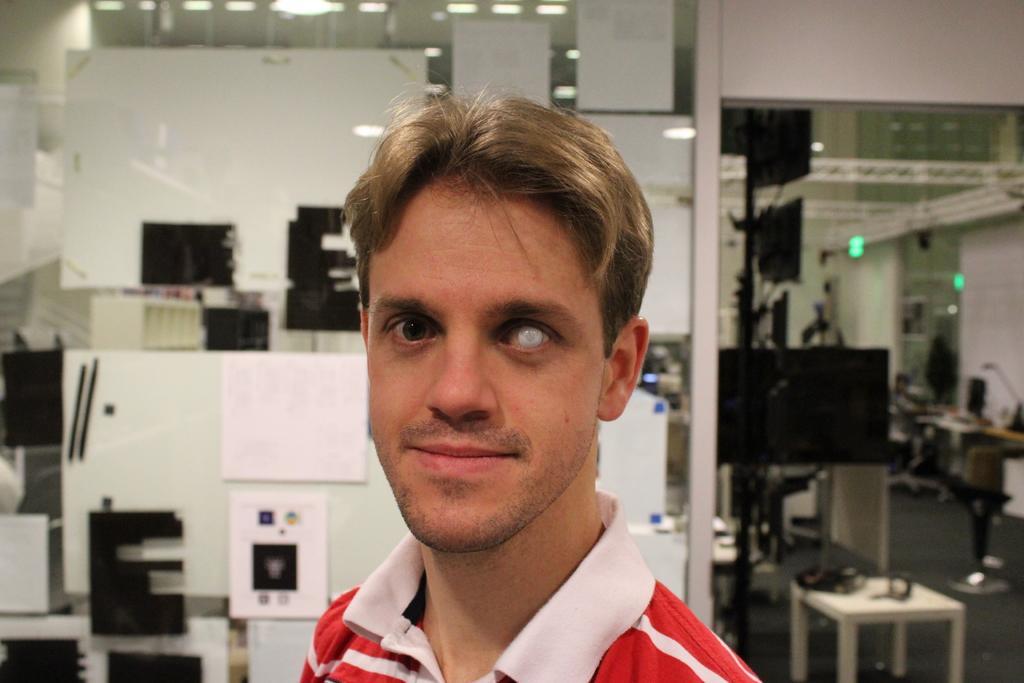Describe this image in one or two sentences. In this image there is a person, and in the background there are some machines, stool, lights. 